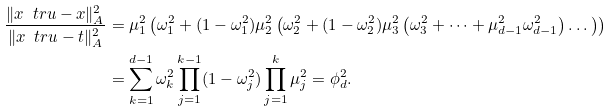Convert formula to latex. <formula><loc_0><loc_0><loc_500><loc_500>\frac { \| x _ { \ } t r u - x \| _ { A } ^ { 2 } } { \| x _ { \ } t r u - t \| _ { A } ^ { 2 } } & = \mu _ { 1 } ^ { 2 } \left ( \omega _ { 1 } ^ { 2 } + ( 1 - \omega _ { 1 } ^ { 2 } ) \mu _ { 2 } ^ { 2 } \left ( \omega _ { 2 } ^ { 2 } + ( 1 - \omega _ { 2 } ^ { 2 } ) \mu _ { 3 } ^ { 2 } \left ( \omega _ { 3 } ^ { 2 } + \dots + \mu _ { d - 1 } ^ { 2 } \omega _ { d - 1 } ^ { 2 } \right ) \dots \right ) \right ) \\ & = \sum _ { k = 1 } ^ { d - 1 } \omega _ { k } ^ { 2 } \prod _ { j = 1 } ^ { k - 1 } ( 1 - \omega _ { j } ^ { 2 } ) \prod _ { j = 1 } ^ { k } \mu _ { j } ^ { 2 } = \phi _ { d } ^ { 2 } .</formula> 